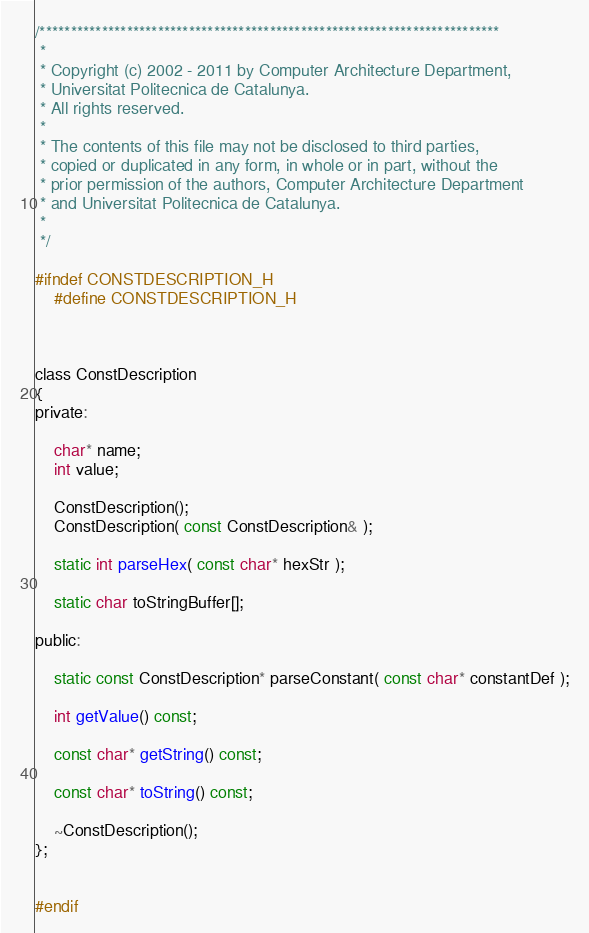Convert code to text. <code><loc_0><loc_0><loc_500><loc_500><_C_>/**************************************************************************
 *
 * Copyright (c) 2002 - 2011 by Computer Architecture Department,
 * Universitat Politecnica de Catalunya.
 * All rights reserved.
 *
 * The contents of this file may not be disclosed to third parties,
 * copied or duplicated in any form, in whole or in part, without the
 * prior permission of the authors, Computer Architecture Department
 * and Universitat Politecnica de Catalunya.
 *
 */

#ifndef CONSTDESCRIPTION_H
    #define CONSTDESCRIPTION_H



class ConstDescription
{
private:
    
    char* name;
    int value;

    ConstDescription();
    ConstDescription( const ConstDescription& );

    static int parseHex( const char* hexStr );

    static char toStringBuffer[];

public:

    static const ConstDescription* parseConstant( const char* constantDef );

    int getValue() const;

    const char* getString() const;

    const char* toString() const;

    ~ConstDescription();
};


#endif
</code> 